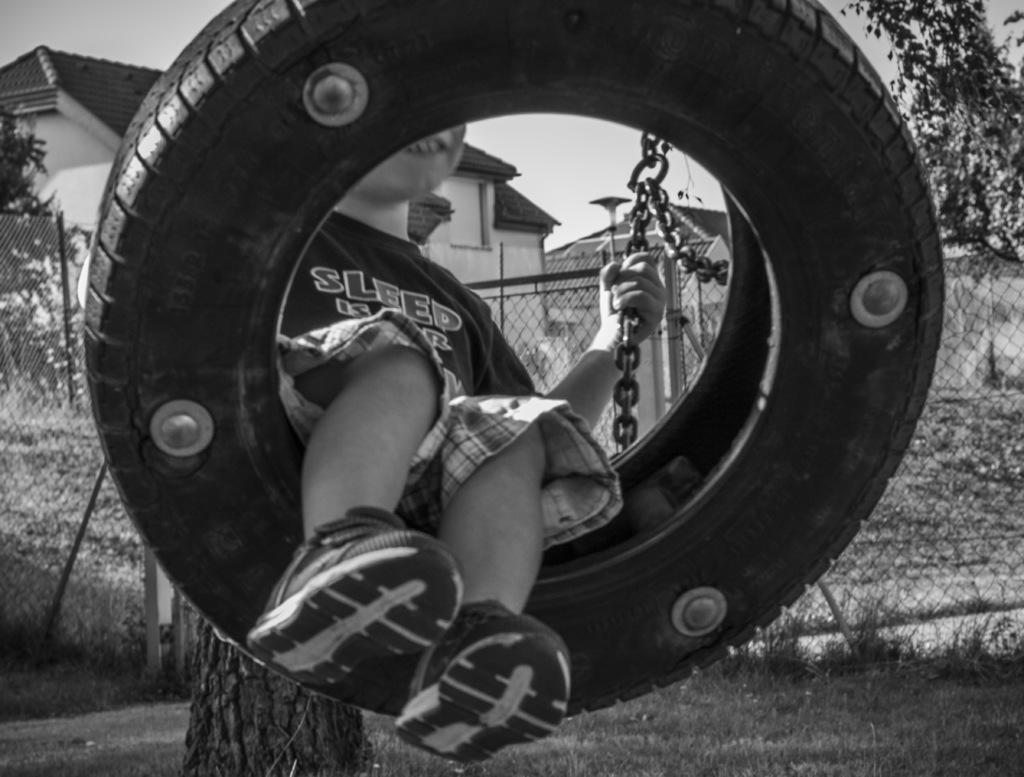In one or two sentences, can you explain what this image depicts? In the center of the picture there is a kid in a swing, he is holding chain. In the background there are trees, fencing, grass, branch and buildings. 